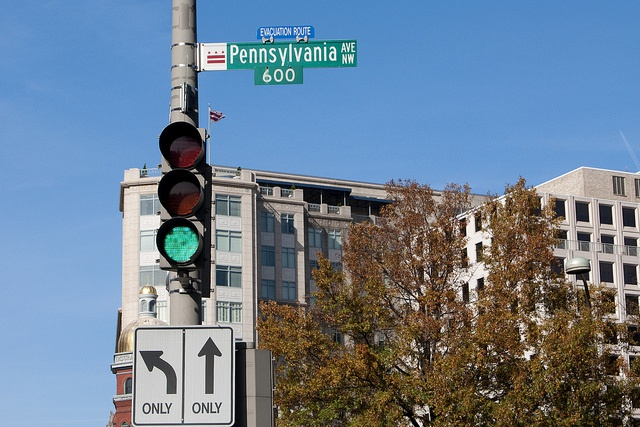Describe the objects in this image and their specific colors. I can see a traffic light in gray, black, darkgray, and maroon tones in this image. 